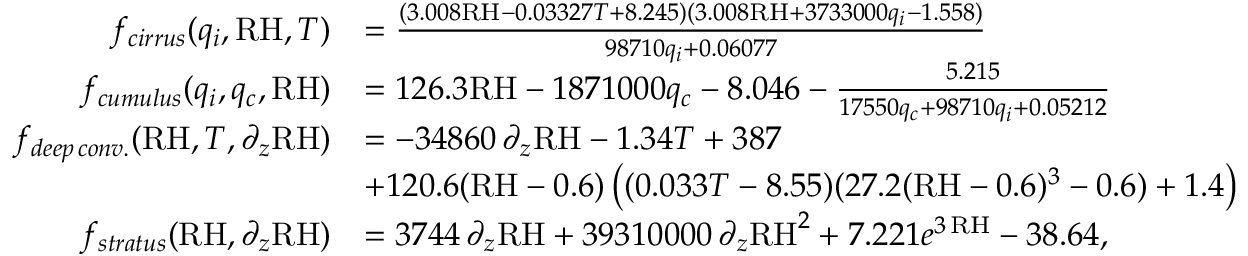Convert formula to latex. <formula><loc_0><loc_0><loc_500><loc_500>\begin{array} { r l } { f _ { c i r r u s } ( q _ { i } , R H , T ) } & { = \frac { ( 3 . 0 0 8 R H - 0 . 0 3 3 2 7 T + 8 . 2 4 5 ) ( 3 . 0 0 8 R H + 3 7 3 3 0 0 0 q _ { i } - 1 . 5 5 8 ) } { 9 8 7 1 0 q _ { i } + 0 . 0 6 0 7 7 } } \\ { f _ { c u m u l u s } ( q _ { i } , q _ { c } , R H ) } & { = 1 2 6 . 3 R H - 1 8 7 1 0 0 0 q _ { c } - 8 . 0 4 6 - \frac { 5 . 2 1 5 } { 1 7 5 5 0 q _ { c } + 9 8 7 1 0 q _ { i } + 0 . 0 5 2 1 2 } } \\ { f _ { d e e p \, c o n v . } ( R H , T , \partial _ { z } R H ) } & { = - 3 4 8 6 0 \, \partial _ { z } R H - 1 . 3 4 T + 3 8 7 } \\ & { + 1 2 0 . 6 ( R H - 0 . 6 ) \left ( ( 0 . 0 3 3 T - 8 . 5 5 ) ( 2 7 . 2 ( R H - 0 . 6 ) ^ { 3 } - 0 . 6 ) + 1 . 4 \right ) } \\ { f _ { s t r a t u s } ( R H , \partial _ { z } R H ) } & { = 3 7 4 4 \, \partial _ { z } R H + 3 9 3 1 0 0 0 0 \, \partial _ { z } R H ^ { 2 } + 7 . 2 2 1 e ^ { 3 \, R H } - 3 8 . 6 4 , } \end{array}</formula> 